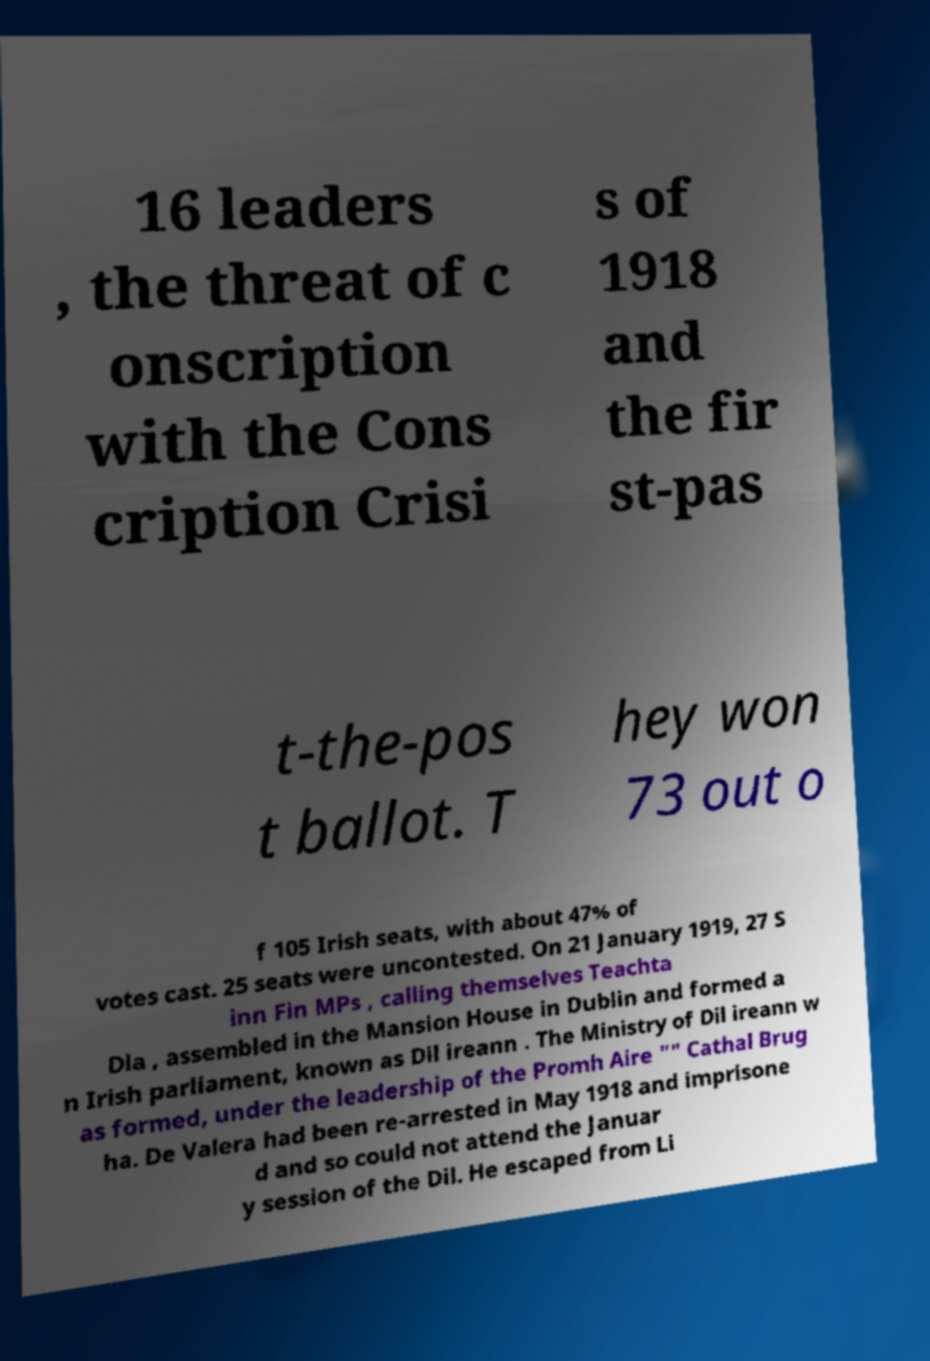Please read and relay the text visible in this image. What does it say? 16 leaders , the threat of c onscription with the Cons cription Crisi s of 1918 and the fir st-pas t-the-pos t ballot. T hey won 73 out o f 105 Irish seats, with about 47% of votes cast. 25 seats were uncontested. On 21 January 1919, 27 S inn Fin MPs , calling themselves Teachta Dla , assembled in the Mansion House in Dublin and formed a n Irish parliament, known as Dil ireann . The Ministry of Dil ireann w as formed, under the leadership of the Promh Aire "" Cathal Brug ha. De Valera had been re-arrested in May 1918 and imprisone d and so could not attend the Januar y session of the Dil. He escaped from Li 